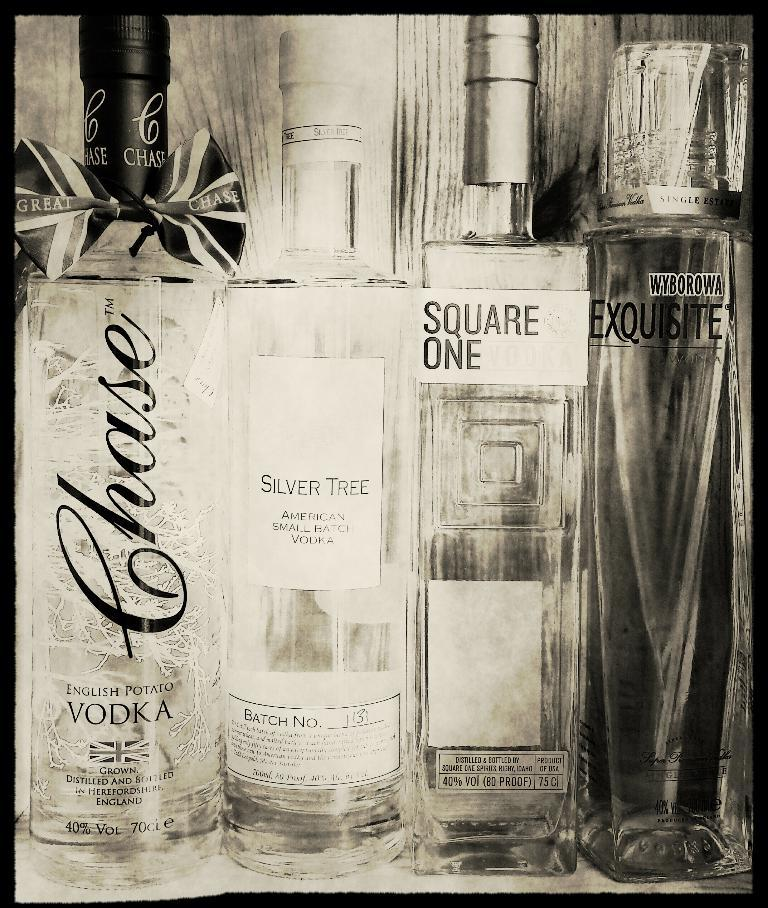<image>
Present a compact description of the photo's key features. bottles of liquor like Square One and Silver Tree next to each other 